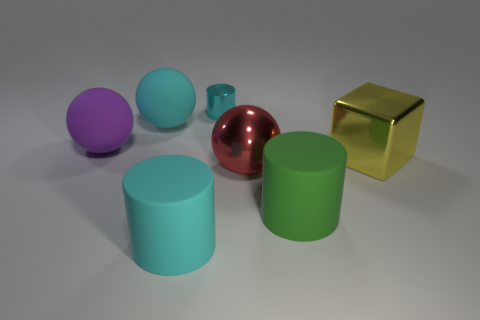Are there any other things that have the same size as the metal cylinder?
Offer a terse response. No. There is a big object in front of the green object; is it the same color as the tiny metallic cylinder?
Ensure brevity in your answer.  Yes. What is the material of the cyan thing that is behind the big green thing and right of the big cyan rubber sphere?
Make the answer very short. Metal. There is a rubber ball behind the large purple matte object; are there any large cubes in front of it?
Provide a short and direct response. Yes. Are the big cyan cylinder and the purple object made of the same material?
Your response must be concise. Yes. What is the shape of the thing that is in front of the large yellow thing and to the right of the metal ball?
Keep it short and to the point. Cylinder. There is a cylinder behind the matte cylinder on the right side of the large cyan matte cylinder; what is its size?
Ensure brevity in your answer.  Small. How many big yellow things have the same shape as the small cyan thing?
Ensure brevity in your answer.  0. Is there any other thing that is the same shape as the yellow thing?
Your answer should be very brief. No. Is there a large thing of the same color as the metallic cylinder?
Your answer should be very brief. Yes. 